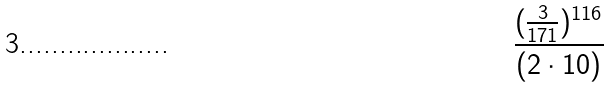Convert formula to latex. <formula><loc_0><loc_0><loc_500><loc_500>\frac { ( \frac { 3 } { 1 7 1 } ) ^ { 1 1 6 } } { ( 2 \cdot 1 0 ) }</formula> 